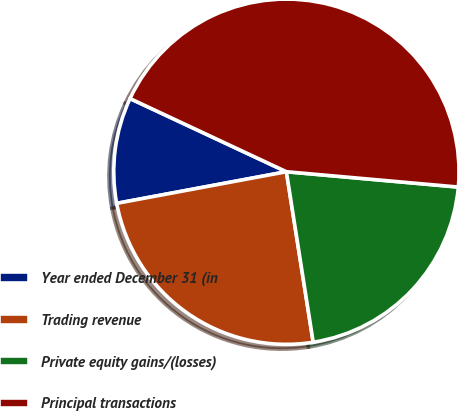<chart> <loc_0><loc_0><loc_500><loc_500><pie_chart><fcel>Year ended December 31 (in<fcel>Trading revenue<fcel>Private equity gains/(losses)<fcel>Principal transactions<nl><fcel>9.9%<fcel>24.55%<fcel>21.1%<fcel>44.45%<nl></chart> 